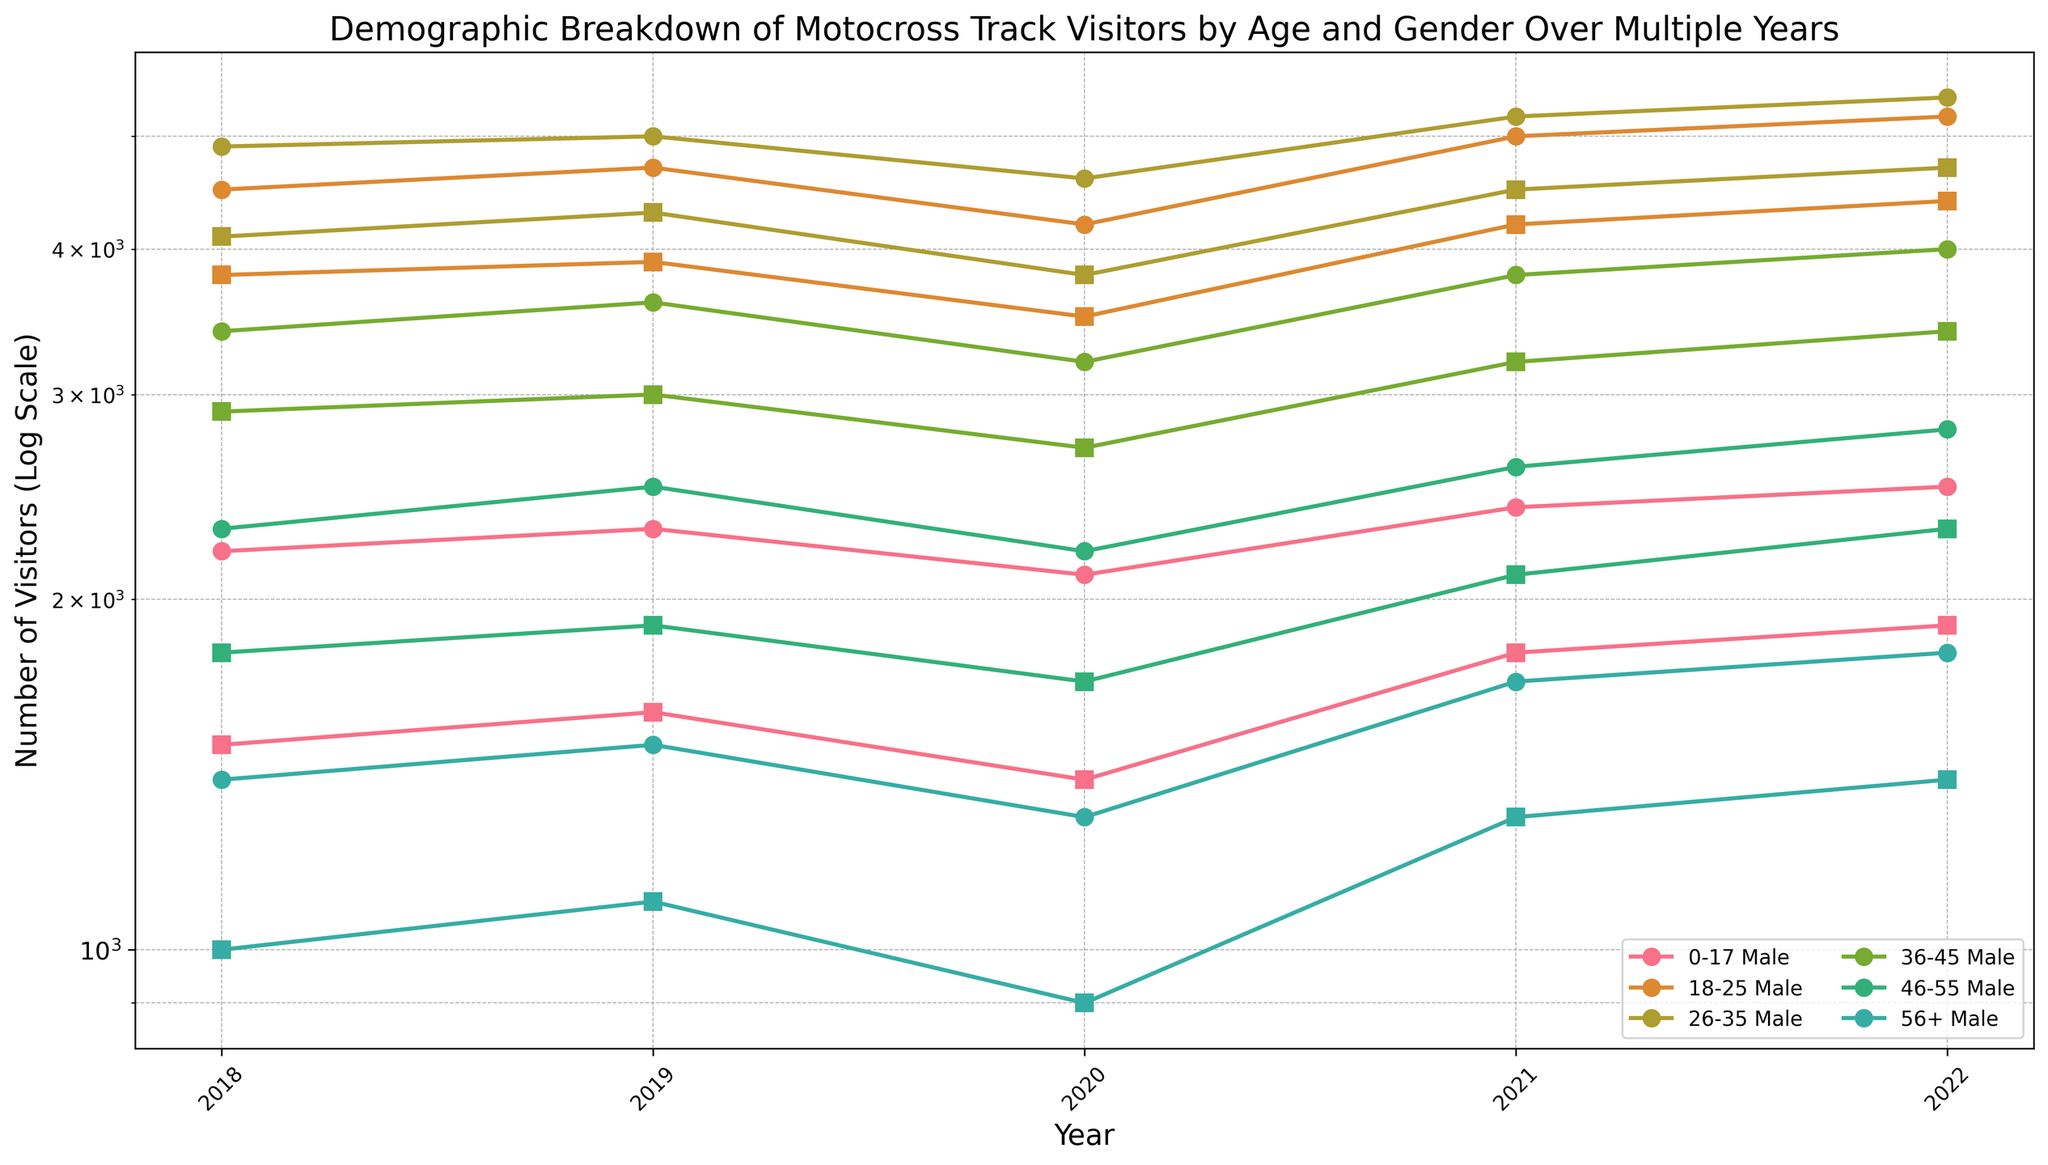What's the overall trend for visitors in the 18-25 age group from 2018 to 2022? To determine the trend, look at the plotted points for the 18-25 age group over the years 2018 to 2022 for both males and females. For males, the visitor count increases each year from 4500 in 2018 to 5200 in 2022. For females, the count also rises from 3800 in 2018 to 4400 in 2022. This indicates an overall increasing trend for visitors in the 18-25 age group.
Answer: Increasing Between which two consecutive years did the female visitors in the 26-35 age group see the highest increase? Examine the plotted points for female visitors in the 26-35 age group. Compare the year's differences: from 2018 to 2019, it increased from 4100 to 4300 (200 increase), from 2019 to 2020, it decreased to 3800, from 2020 to 2021 it increased to 4500 (700 increase), and from 2021 to 2022, it increased to 4700 (200 increase). The highest increase is between 2020 and 2021.
Answer: 2020 to 2021 Which age group had the least number of visitors in 2020? Review the plotted points for all age groups in 2020. Compare the visitor counts: 0-17 (2100 males, 1400 females), 18-25 (4200 males, 3500 females), 26-35 (4600 males, 3800 females), 36-45 (3200 males, 2700 females), 46-55 (2200 males, 1700 females), 56+ (1300 males, 900 females). The 56+ age group had the least visitors.
Answer: 56+ Which gender had more visitors in the 36-45 age group each year from 2018 to 2022? Compare the plotted points for males and females in the 36-45 age group for each year. For each year from 2018 to 2022, male visitors consistently have higher counts compared to female visitors (3400 vs 2900 in 2018, 3600 vs 3000 in 2019, 3200 vs 2700 in 2020, 3800 vs 3200 in 2021, and 4000 vs 3400 in 2022).
Answer: Male What's the average number of male visitors across all age groups in the year 2019? For males in 2019, sum the visitor counts across all age groups (2300 + 4700 + 5000 + 3600 + 2500 + 1500) and divide by the number of age groups (6). This gives (2300 + 4700 + 5000 + 3600 + 2500 + 1500) / 6 = 19600 / 6.
Answer: 3267 In which age group did both male and female visitors see a decline from 2019 to 2020? Compare the visitor counts from 2019 to 2020 for each gender in each age group. The only age group where both genders saw a decline is the 26-35 age group (males from 5000 to 4600 and females from 4300 to 3800).
Answer: 26-35 What is the difference in the number of male and female visitors in the 0-17 age group in 2022? For the 0-17 age group in 2022, compare the visitor counts for males and females: 2500 males and 1900 females. The difference is 2500 - 1900.
Answer: 600 Which age group showed the most consistent increase in visitors for both genders from 2018 to 2022? Examine the sequence of plotted points for each age group across years for both genders. The 18-25 age group consistently shows an increase each year for both males (4500 to 5200) and females (3800 to 4400).
Answer: 18-25 How does the number of visitors in the 46-55 age group for both genders combined compare between 2020 and 2022? For 2020, add up the visitor counts for males and females in the 46-55 age group (2200 males + 1700 females = 3900). For 2022, repeat the process (2800 males + 2300 females = 5100). Compare the sums to see an increase from 3900 to 5100.
Answer: 5100 in 2022, increased from 3900 in 2020 What's the total number of visitors in the 56+ age group in 2021? Sum the number of visitors for males and females in the 56+ age group in 2021 (1700 males + 1300 females).
Answer: 3000 